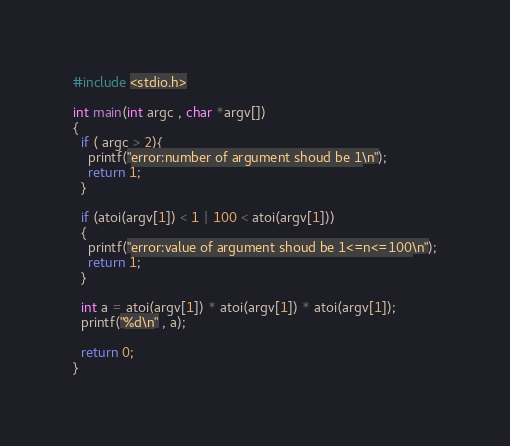<code> <loc_0><loc_0><loc_500><loc_500><_C_>#include <stdio.h>

int main(int argc , char *argv[])
{
  if ( argc > 2){
    printf("error:number of argument shoud be 1\n");
    return 1;
  }

  if (atoi(argv[1]) < 1 | 100 < atoi(argv[1]))
  {
    printf("error:value of argument shoud be 1<=n<=100\n");
    return 1;
  }

  int a = atoi(argv[1]) * atoi(argv[1]) * atoi(argv[1]);
  printf("%d\n" , a);

  return 0;
}</code> 